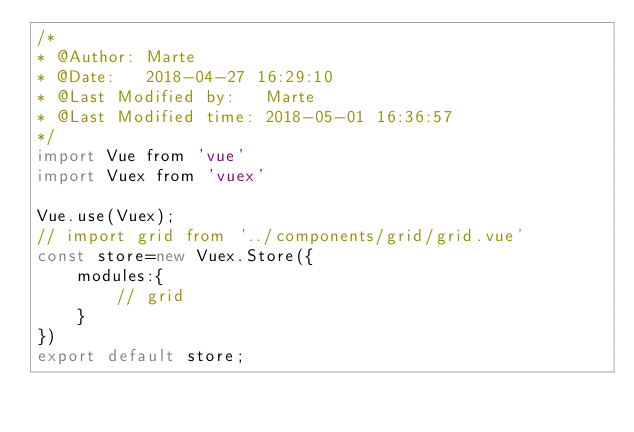<code> <loc_0><loc_0><loc_500><loc_500><_JavaScript_>/* 
* @Author: Marte
* @Date:   2018-04-27 16:29:10
* @Last Modified by:   Marte
* @Last Modified time: 2018-05-01 16:36:57
*/
import Vue from 'vue'
import Vuex from 'vuex'

Vue.use(Vuex);
// import grid from '../components/grid/grid.vue'
const store=new Vuex.Store({
    modules:{
        // grid
    }
})
export default store;</code> 